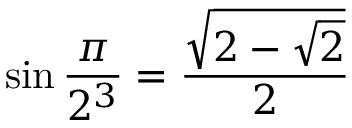<formula> <loc_0><loc_0><loc_500><loc_500>\sin { \frac { \pi } { 2 ^ { 3 } } } = { \frac { \sqrt { 2 - { \sqrt { 2 } } } } { 2 } }</formula> 